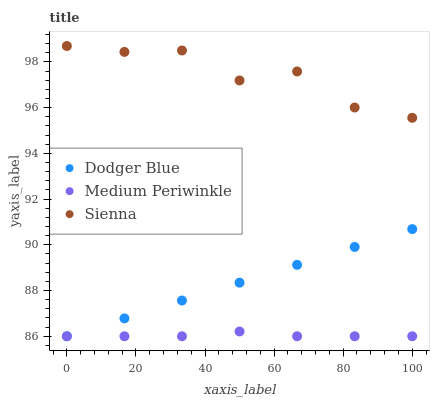Does Medium Periwinkle have the minimum area under the curve?
Answer yes or no. Yes. Does Sienna have the maximum area under the curve?
Answer yes or no. Yes. Does Dodger Blue have the minimum area under the curve?
Answer yes or no. No. Does Dodger Blue have the maximum area under the curve?
Answer yes or no. No. Is Dodger Blue the smoothest?
Answer yes or no. Yes. Is Sienna the roughest?
Answer yes or no. Yes. Is Medium Periwinkle the smoothest?
Answer yes or no. No. Is Medium Periwinkle the roughest?
Answer yes or no. No. Does Medium Periwinkle have the lowest value?
Answer yes or no. Yes. Does Sienna have the highest value?
Answer yes or no. Yes. Does Dodger Blue have the highest value?
Answer yes or no. No. Is Dodger Blue less than Sienna?
Answer yes or no. Yes. Is Sienna greater than Dodger Blue?
Answer yes or no. Yes. Does Dodger Blue intersect Medium Periwinkle?
Answer yes or no. Yes. Is Dodger Blue less than Medium Periwinkle?
Answer yes or no. No. Is Dodger Blue greater than Medium Periwinkle?
Answer yes or no. No. Does Dodger Blue intersect Sienna?
Answer yes or no. No. 